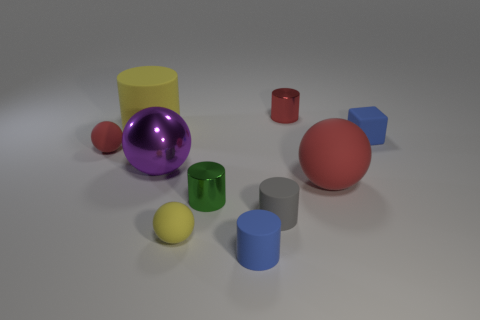Do the blue rubber thing that is behind the small green shiny object and the yellow thing in front of the gray thing have the same size?
Your answer should be very brief. Yes. How many things are either purple shiny balls or large purple balls that are to the left of the big rubber ball?
Give a very brief answer. 1. There is a metal cylinder that is behind the yellow cylinder; what size is it?
Offer a very short reply. Small. Are there fewer big red matte balls on the left side of the rubber cube than tiny spheres that are in front of the tiny green metallic cylinder?
Offer a terse response. No. The small object that is both on the left side of the tiny green cylinder and in front of the big red matte ball is made of what material?
Your answer should be very brief. Rubber. There is a tiny blue object in front of the rubber thing that is on the left side of the big matte cylinder; what shape is it?
Your answer should be compact. Cylinder. Is the rubber cube the same color as the large metal ball?
Give a very brief answer. No. How many blue things are big rubber cylinders or tiny shiny cylinders?
Your answer should be compact. 0. Are there any small gray things right of the red metal object?
Give a very brief answer. No. How big is the blue cylinder?
Your answer should be compact. Small. 